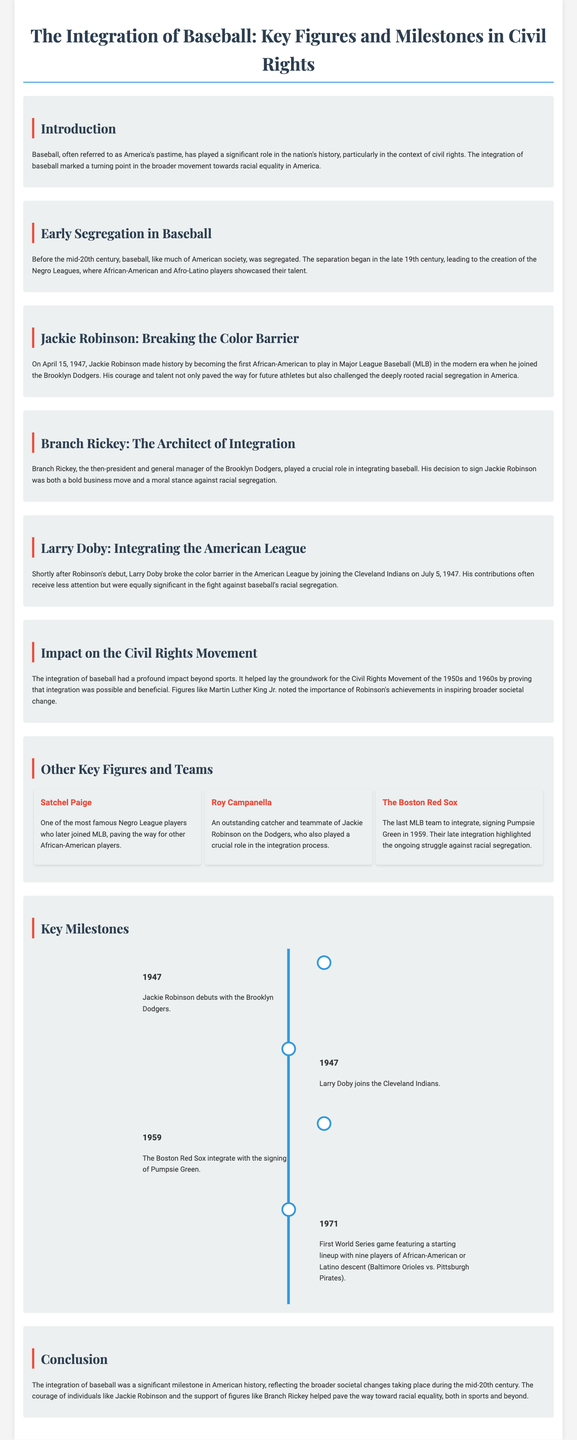What date did Jackie Robinson debut in MLB? The document states Jackie Robinson made his debut on April 15, 1947.
Answer: April 15, 1947 Who was the first African-American to play in Major League Baseball? The document identifies Jackie Robinson as the first African-American to play in MLB in the modern era.
Answer: Jackie Robinson Which team did Larry Doby join to break the color barrier in the American League? The document notes that Larry Doby joined the Cleveland Indians on July 5, 1947.
Answer: Cleveland Indians What year did the Boston Red Sox integrate? The document says the Boston Red Sox integrated in 1959 with the signing of Pumpsie Green.
Answer: 1959 Who signed Jackie Robinson to the Brooklyn Dodgers? The document mentions Branch Rickey as the president and general manager who signed Jackie Robinson.
Answer: Branch Rickey What milestone occurred in 1971 related to World Series lineups? The document states that the first World Series game with a starting lineup featuring nine players of African-American or Latino descent took place.
Answer: Nine players Why was the integration of baseball significant beyond sports? The document explains that it helped lay the groundwork for the Civil Rights Movement by proving integration was possible and beneficial.
Answer: Civil Rights Movement Who noted the importance of Jackie Robinson's achievements for societal change? The document cites Martin Luther King Jr. as a figure who recognized the impact of Robinson's achievements.
Answer: Martin Luther King Jr Which position did Roy Campanella play? The document describes Roy Campanella as an outstanding catcher, emphasizing his role in the integration process.
Answer: Catcher 